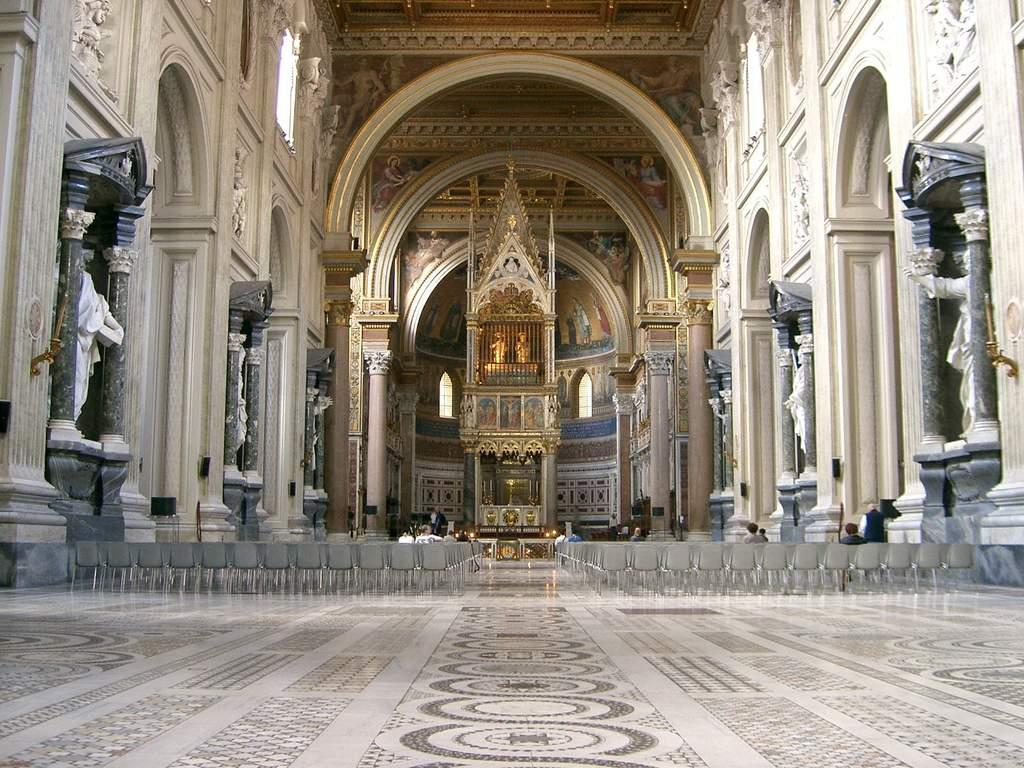Where is the location of the image? The image is inside a building. What type of furniture can be seen in the image? There are chairs in the image. What architectural features are present in the image? There are pillars, arches, statues, and sculptures in the image. What type of creature can be seen living in the tent in the image? There is no tent present in the image, and therefore no creature living in a tent can be observed. 